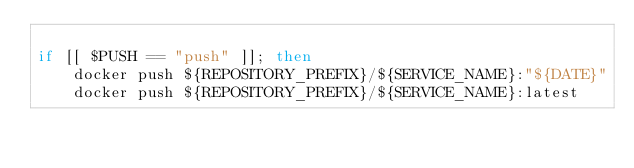Convert code to text. <code><loc_0><loc_0><loc_500><loc_500><_Bash_>
if [[ $PUSH == "push" ]]; then
    docker push ${REPOSITORY_PREFIX}/${SERVICE_NAME}:"${DATE}"
    docker push ${REPOSITORY_PREFIX}/${SERVICE_NAME}:latest</code> 